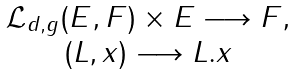<formula> <loc_0><loc_0><loc_500><loc_500>\begin{array} { c c c c } \mathcal { L } _ { d , g } ( E , F ) \times E \longrightarrow F , \\ ( L , x ) \longrightarrow L . x \end{array}</formula> 